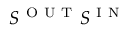<formula> <loc_0><loc_0><loc_500><loc_500>S ^ { O U T } S ^ { I N }</formula> 